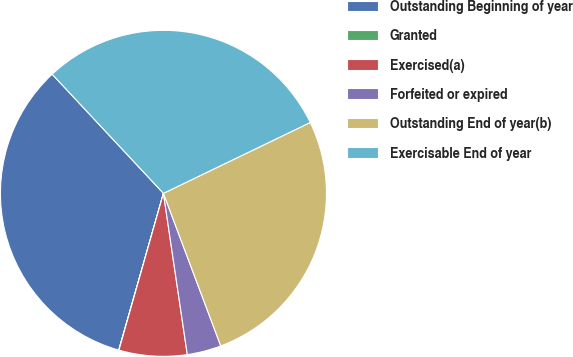Convert chart. <chart><loc_0><loc_0><loc_500><loc_500><pie_chart><fcel>Outstanding Beginning of year<fcel>Granted<fcel>Exercised(a)<fcel>Forfeited or expired<fcel>Outstanding End of year(b)<fcel>Exercisable End of year<nl><fcel>33.62%<fcel>0.02%<fcel>6.74%<fcel>3.38%<fcel>26.44%<fcel>29.8%<nl></chart> 